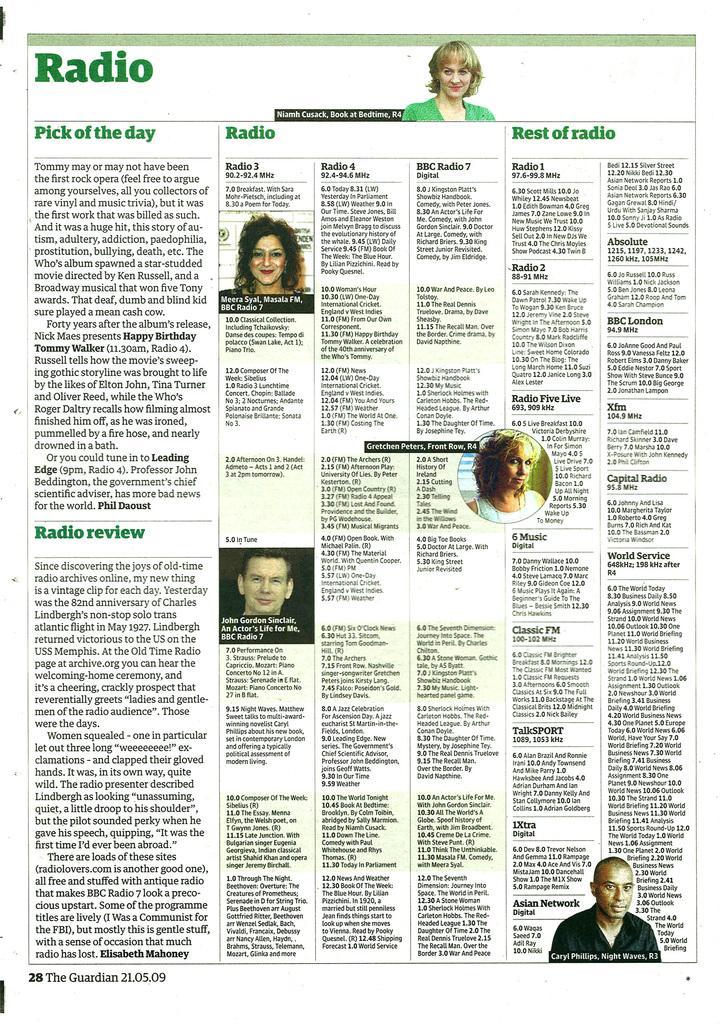Please provide a concise description of this image. Here in this picture we can see a newspaper with some text and pictures printed over there. 